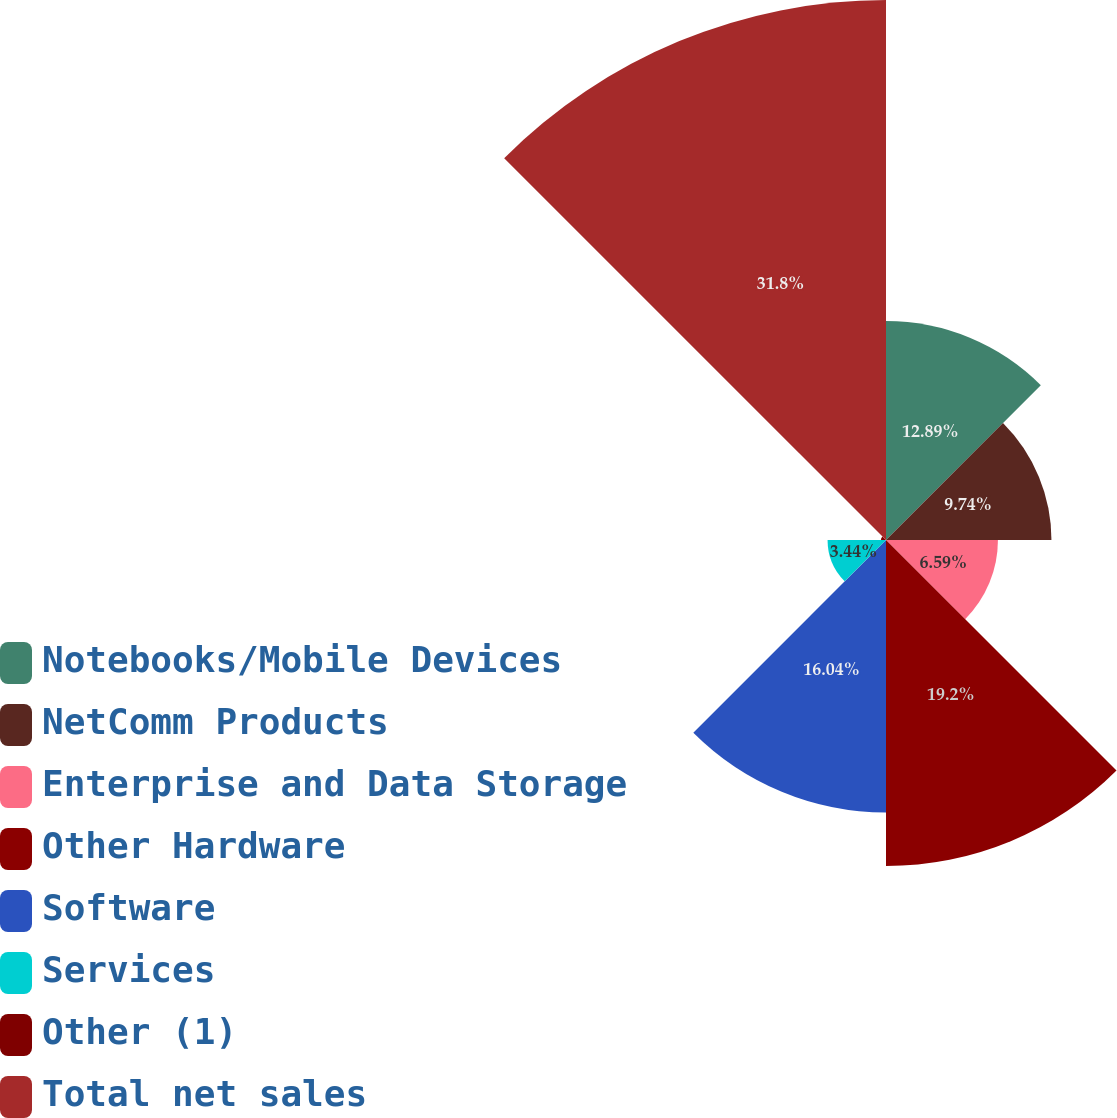<chart> <loc_0><loc_0><loc_500><loc_500><pie_chart><fcel>Notebooks/Mobile Devices<fcel>NetComm Products<fcel>Enterprise and Data Storage<fcel>Other Hardware<fcel>Software<fcel>Services<fcel>Other (1)<fcel>Total net sales<nl><fcel>12.89%<fcel>9.74%<fcel>6.59%<fcel>19.19%<fcel>16.04%<fcel>3.44%<fcel>0.3%<fcel>31.79%<nl></chart> 